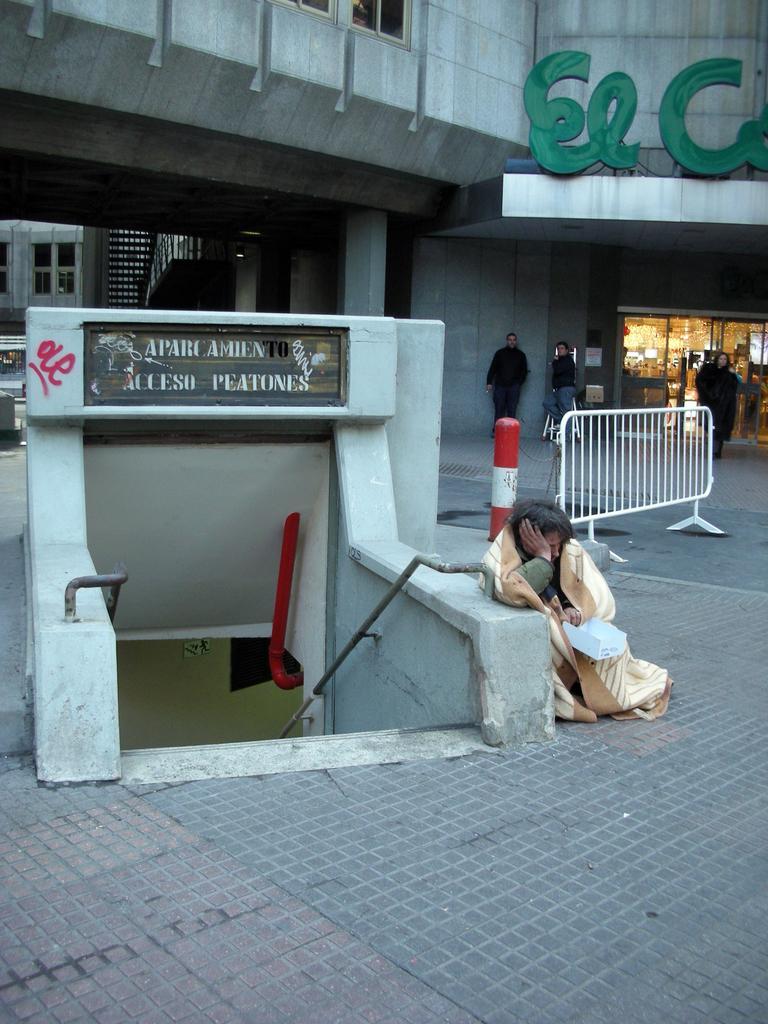In one or two sentences, can you explain what this image depicts? This image is taken outdoors. At the bottom of the image there is a floor. In the background there is a building. A few people are walking on the floor. There is a safety cone. In the middle of the image there is a board with a text on it. There is a wall. On the right side of the image there is a gate. A person is sitting on the floor. 